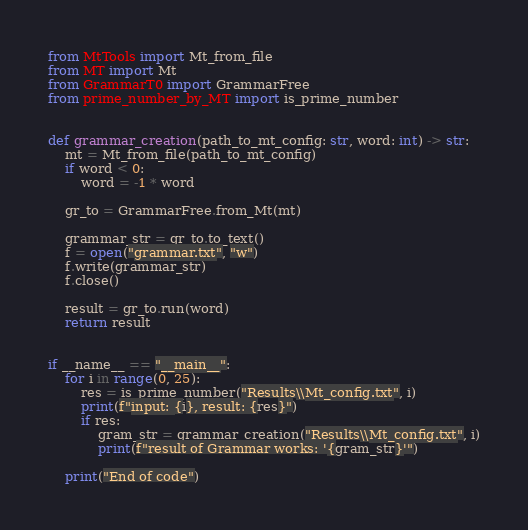<code> <loc_0><loc_0><loc_500><loc_500><_Python_>from MtTools import Mt_from_file
from MT import Mt
from GrammarT0 import GrammarFree
from prime_number_by_MT import is_prime_number


def grammar_creation(path_to_mt_config: str, word: int) -> str:
    mt = Mt_from_file(path_to_mt_config)
    if word < 0:
        word = -1 * word

    gr_to = GrammarFree.from_Mt(mt)

    grammar_str = gr_to.to_text()
    f = open("grammar.txt", "w")
    f.write(grammar_str)
    f.close()

    result = gr_to.run(word)
    return result


if __name__ == "__main__":
    for i in range(0, 25):
        res = is_prime_number("Results\\Mt_config.txt", i)
        print(f"input: {i}, result: {res}")
        if res:
            gram_str = grammar_creation("Results\\Mt_config.txt", i)
            print(f"result of Grammar works: '{gram_str}'")

    print("End of code")
</code> 